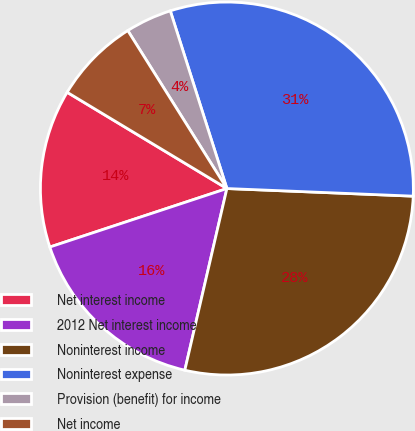Convert chart. <chart><loc_0><loc_0><loc_500><loc_500><pie_chart><fcel>Net interest income<fcel>2012 Net interest income<fcel>Noninterest income<fcel>Noninterest expense<fcel>Provision (benefit) for income<fcel>Net income<nl><fcel>13.71%<fcel>16.3%<fcel>27.97%<fcel>30.56%<fcel>4.01%<fcel>7.45%<nl></chart> 